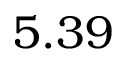<formula> <loc_0><loc_0><loc_500><loc_500>5 . 3 9</formula> 